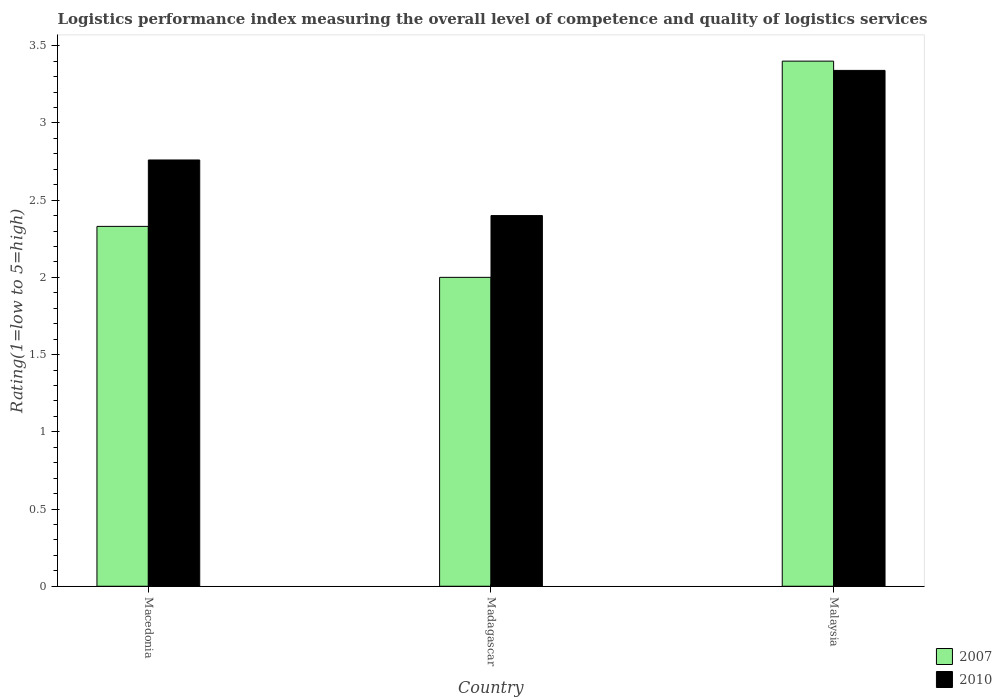How many different coloured bars are there?
Offer a terse response. 2. Are the number of bars per tick equal to the number of legend labels?
Your answer should be very brief. Yes. Are the number of bars on each tick of the X-axis equal?
Keep it short and to the point. Yes. What is the label of the 2nd group of bars from the left?
Offer a terse response. Madagascar. What is the Logistic performance index in 2007 in Madagascar?
Ensure brevity in your answer.  2. Across all countries, what is the maximum Logistic performance index in 2010?
Your answer should be very brief. 3.34. In which country was the Logistic performance index in 2010 maximum?
Keep it short and to the point. Malaysia. In which country was the Logistic performance index in 2010 minimum?
Offer a very short reply. Madagascar. What is the difference between the Logistic performance index in 2010 in Macedonia and that in Malaysia?
Provide a short and direct response. -0.58. What is the difference between the Logistic performance index in 2007 in Macedonia and the Logistic performance index in 2010 in Madagascar?
Your response must be concise. -0.07. What is the average Logistic performance index in 2007 per country?
Provide a short and direct response. 2.58. What is the difference between the Logistic performance index of/in 2007 and Logistic performance index of/in 2010 in Malaysia?
Your answer should be compact. 0.06. In how many countries, is the Logistic performance index in 2007 greater than 3?
Provide a short and direct response. 1. What is the ratio of the Logistic performance index in 2007 in Macedonia to that in Madagascar?
Provide a short and direct response. 1.17. Is the difference between the Logistic performance index in 2007 in Macedonia and Malaysia greater than the difference between the Logistic performance index in 2010 in Macedonia and Malaysia?
Your answer should be very brief. No. What is the difference between the highest and the second highest Logistic performance index in 2010?
Offer a terse response. -0.36. What is the difference between the highest and the lowest Logistic performance index in 2010?
Make the answer very short. 0.94. In how many countries, is the Logistic performance index in 2007 greater than the average Logistic performance index in 2007 taken over all countries?
Offer a very short reply. 1. What does the 2nd bar from the left in Madagascar represents?
Provide a short and direct response. 2010. What does the 2nd bar from the right in Madagascar represents?
Your answer should be compact. 2007. Are all the bars in the graph horizontal?
Give a very brief answer. No. What is the difference between two consecutive major ticks on the Y-axis?
Give a very brief answer. 0.5. Are the values on the major ticks of Y-axis written in scientific E-notation?
Give a very brief answer. No. Does the graph contain grids?
Keep it short and to the point. No. What is the title of the graph?
Your answer should be very brief. Logistics performance index measuring the overall level of competence and quality of logistics services. What is the label or title of the X-axis?
Give a very brief answer. Country. What is the label or title of the Y-axis?
Your response must be concise. Rating(1=low to 5=high). What is the Rating(1=low to 5=high) of 2007 in Macedonia?
Give a very brief answer. 2.33. What is the Rating(1=low to 5=high) in 2010 in Macedonia?
Keep it short and to the point. 2.76. What is the Rating(1=low to 5=high) of 2007 in Malaysia?
Ensure brevity in your answer.  3.4. What is the Rating(1=low to 5=high) of 2010 in Malaysia?
Your answer should be compact. 3.34. Across all countries, what is the maximum Rating(1=low to 5=high) in 2010?
Make the answer very short. 3.34. What is the total Rating(1=low to 5=high) in 2007 in the graph?
Make the answer very short. 7.73. What is the difference between the Rating(1=low to 5=high) of 2007 in Macedonia and that in Madagascar?
Keep it short and to the point. 0.33. What is the difference between the Rating(1=low to 5=high) of 2010 in Macedonia and that in Madagascar?
Give a very brief answer. 0.36. What is the difference between the Rating(1=low to 5=high) in 2007 in Macedonia and that in Malaysia?
Offer a terse response. -1.07. What is the difference between the Rating(1=low to 5=high) of 2010 in Macedonia and that in Malaysia?
Give a very brief answer. -0.58. What is the difference between the Rating(1=low to 5=high) in 2007 in Madagascar and that in Malaysia?
Provide a succinct answer. -1.4. What is the difference between the Rating(1=low to 5=high) in 2010 in Madagascar and that in Malaysia?
Give a very brief answer. -0.94. What is the difference between the Rating(1=low to 5=high) in 2007 in Macedonia and the Rating(1=low to 5=high) in 2010 in Madagascar?
Provide a succinct answer. -0.07. What is the difference between the Rating(1=low to 5=high) of 2007 in Macedonia and the Rating(1=low to 5=high) of 2010 in Malaysia?
Make the answer very short. -1.01. What is the difference between the Rating(1=low to 5=high) of 2007 in Madagascar and the Rating(1=low to 5=high) of 2010 in Malaysia?
Ensure brevity in your answer.  -1.34. What is the average Rating(1=low to 5=high) in 2007 per country?
Provide a succinct answer. 2.58. What is the average Rating(1=low to 5=high) of 2010 per country?
Ensure brevity in your answer.  2.83. What is the difference between the Rating(1=low to 5=high) in 2007 and Rating(1=low to 5=high) in 2010 in Macedonia?
Make the answer very short. -0.43. What is the difference between the Rating(1=low to 5=high) in 2007 and Rating(1=low to 5=high) in 2010 in Madagascar?
Offer a terse response. -0.4. What is the ratio of the Rating(1=low to 5=high) in 2007 in Macedonia to that in Madagascar?
Your answer should be very brief. 1.17. What is the ratio of the Rating(1=low to 5=high) of 2010 in Macedonia to that in Madagascar?
Give a very brief answer. 1.15. What is the ratio of the Rating(1=low to 5=high) of 2007 in Macedonia to that in Malaysia?
Your answer should be compact. 0.69. What is the ratio of the Rating(1=low to 5=high) in 2010 in Macedonia to that in Malaysia?
Make the answer very short. 0.83. What is the ratio of the Rating(1=low to 5=high) in 2007 in Madagascar to that in Malaysia?
Give a very brief answer. 0.59. What is the ratio of the Rating(1=low to 5=high) in 2010 in Madagascar to that in Malaysia?
Offer a terse response. 0.72. What is the difference between the highest and the second highest Rating(1=low to 5=high) of 2007?
Keep it short and to the point. 1.07. What is the difference between the highest and the second highest Rating(1=low to 5=high) of 2010?
Offer a terse response. 0.58. What is the difference between the highest and the lowest Rating(1=low to 5=high) of 2007?
Make the answer very short. 1.4. What is the difference between the highest and the lowest Rating(1=low to 5=high) in 2010?
Keep it short and to the point. 0.94. 